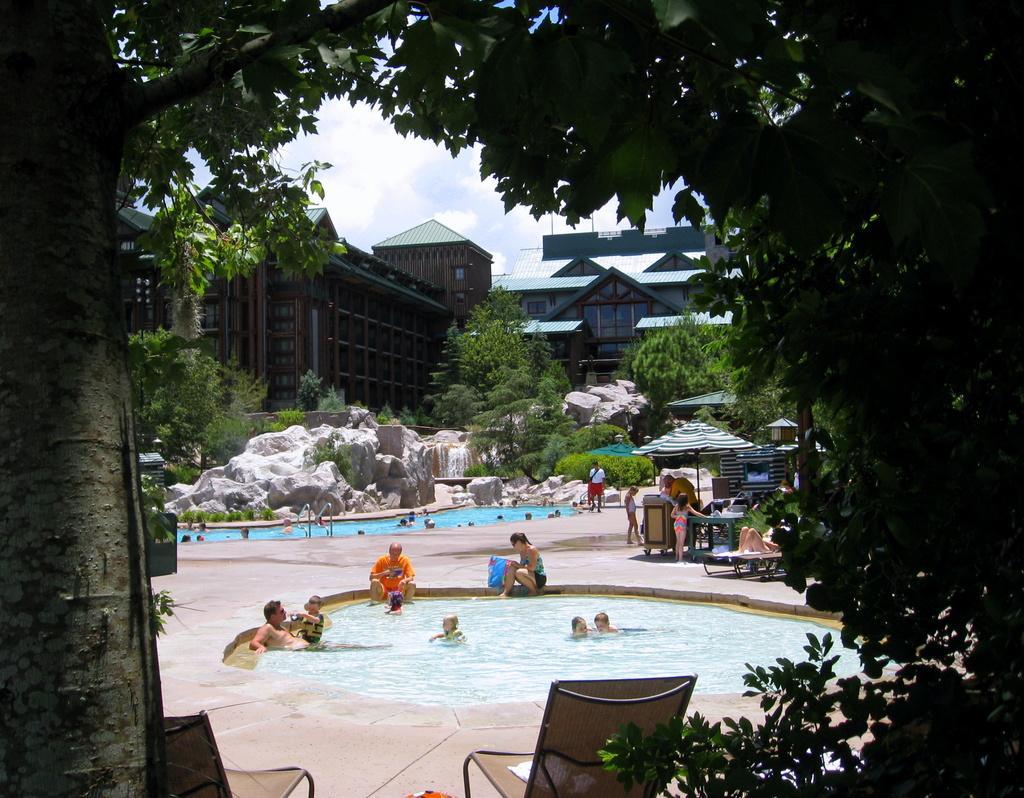In one or two sentences, can you explain what this image depicts? In the foreground of the image there is a huge tree. At the center of the image there is a swimming pool. In the swimming pool there are few persons. In the background there are buildings, trees and sky. 